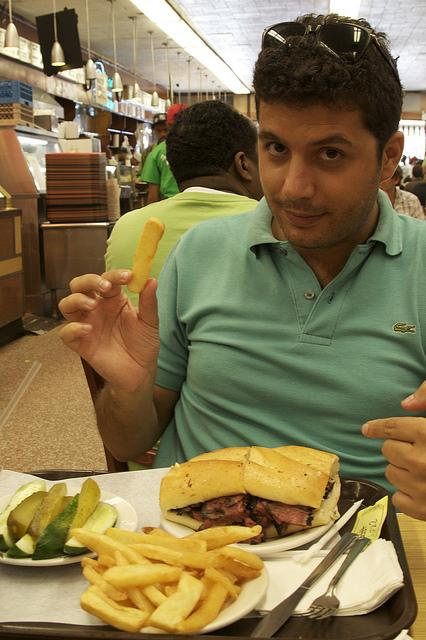The type of restaurant the man is eating at is more likely a what? fast food 